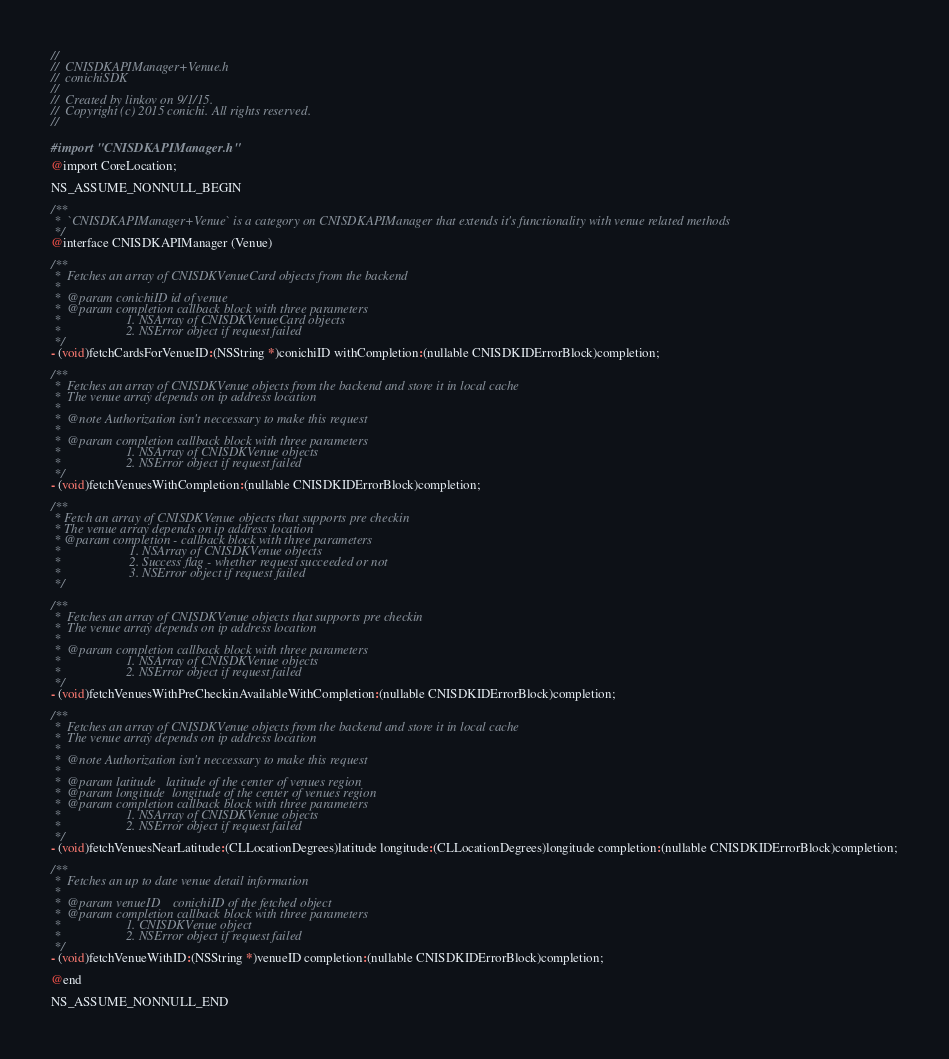<code> <loc_0><loc_0><loc_500><loc_500><_C_>//
//  CNISDKAPIManager+Venue.h
//  conichiSDK
//
//  Created by linkov on 9/1/15.
//  Copyright (c) 2015 conichi. All rights reserved.
//

#import "CNISDKAPIManager.h"

@import CoreLocation;

NS_ASSUME_NONNULL_BEGIN

/**
 *  `CNISDKAPIManager+Venue` is a category on CNISDKAPIManager that extends it's functionality with venue related methods
 */
@interface CNISDKAPIManager (Venue)

/**
 *  Fetches an array of CNISDKVenueCard objects from the backend
 *
 *  @param conichiID id of venue
 *  @param completion callback block with three parameters
 *                    1. NSArray of CNISDKVenueCard objects
 *                    2. NSError object if request failed
 */
- (void)fetchCardsForVenueID:(NSString *)conichiID withCompletion:(nullable CNISDKIDErrorBlock)completion;

/**
 *  Fetches an array of CNISDKVenue objects from the backend and store it in local cache
 *  The venue array depends on ip address location
 *
 *  @note Authorization isn't neccessary to make this request
 *
 *  @param completion callback block with three parameters
 *                    1. NSArray of CNISDKVenue objects
 *                    2. NSError object if request failed
 */
- (void)fetchVenuesWithCompletion:(nullable CNISDKIDErrorBlock)completion;

/**
 * Fetch an array of CNISDKVenue objects that supports pre checkin
 * The venue array depends on ip address location
 * @param completion - callback block with three parameters
 *                     1. NSArray of CNISDKVenue objects
 *                     2. Success flag - whether request succeeded or not
 *                     3. NSError object if request failed
 */

/**
 *  Fetches an array of CNISDKVenue objects that supports pre checkin
 *  The venue array depends on ip address location
 *
 *  @param completion callback block with three parameters
 *                    1. NSArray of CNISDKVenue objects
 *                    2. NSError object if request failed
 */
- (void)fetchVenuesWithPreCheckinAvailableWithCompletion:(nullable CNISDKIDErrorBlock)completion;

/**
 *  Fetches an array of CNISDKVenue objects from the backend and store it in local cache
 *  The venue array depends on ip address location
 *
 *  @note Authorization isn't neccessary to make this request
 *
 *  @param latitude   latitude of the center of venues region
 *  @param longitude  longitude of the center of venues region
 *  @param completion callback block with three parameters
 *                    1. NSArray of CNISDKVenue objects
 *                    2. NSError object if request failed
 */
- (void)fetchVenuesNearLatitude:(CLLocationDegrees)latitude longitude:(CLLocationDegrees)longitude completion:(nullable CNISDKIDErrorBlock)completion;

/**
 *  Fetches an up to date venue detail information
 *
 *  @param venueID    conichiID of the fetched object
 *  @param completion callback block with three parameters
 *                    1. CNISDKVenue object
 *                    2. NSError object if request failed
 */
- (void)fetchVenueWithID:(NSString *)venueID completion:(nullable CNISDKIDErrorBlock)completion;

@end

NS_ASSUME_NONNULL_END
</code> 